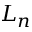<formula> <loc_0><loc_0><loc_500><loc_500>L _ { n }</formula> 